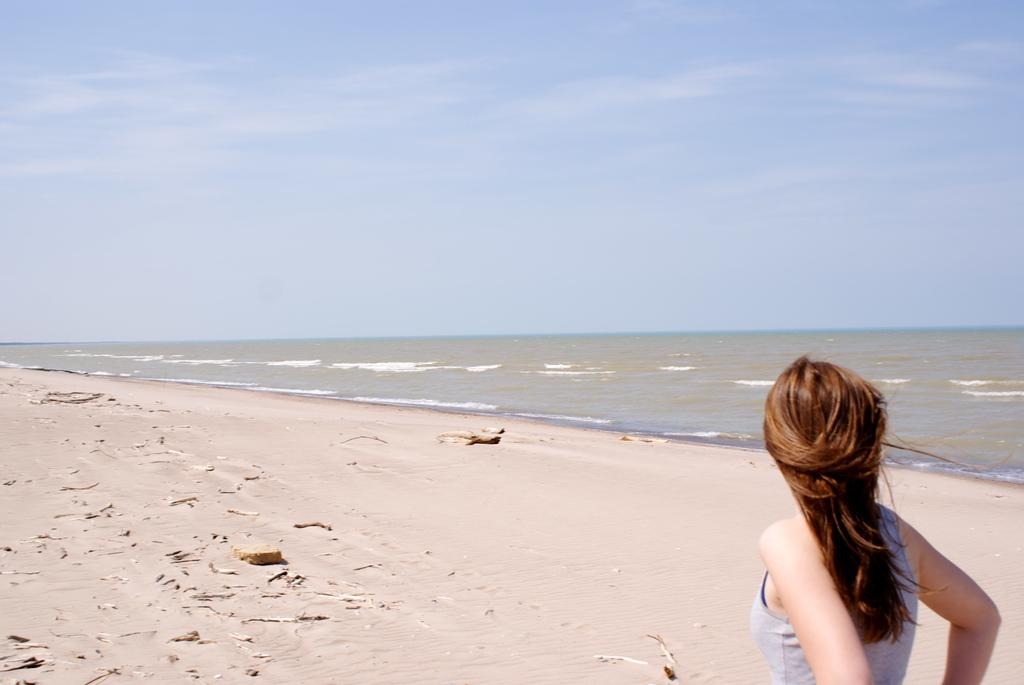Where is the woman located in the image? The woman is in the bottom right of the image. What is the setting of the image? The image is taken at a sea beach. What can be seen in the background of the image? There is sea visible in the background of the image. How is the weather in the image? The sky is clear in the image, suggesting good weather. What type of club does the woman belong to in the image? There is no indication in the image that the woman belongs to any club. 